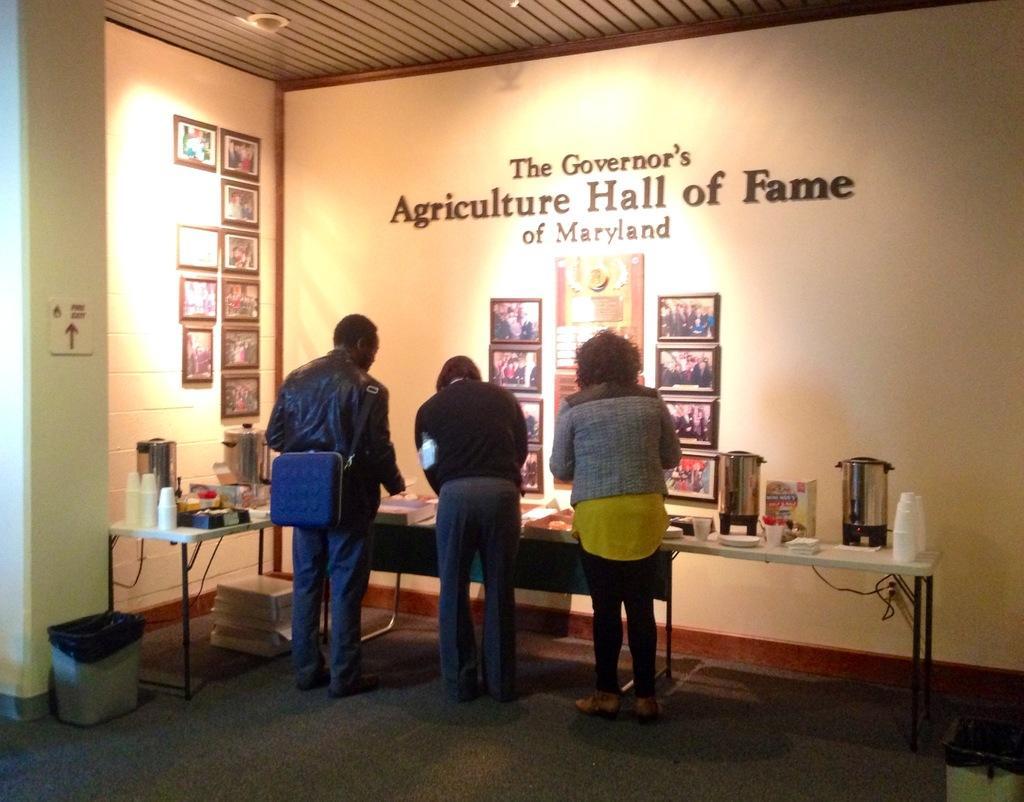Could you give a brief overview of what you see in this image? In this image I see 3 persons who are standing and I can also see this man is carrying a bag and I see tables in front of them on which there are many things. I see a wall over here on which there are many frames and I see few words over here. 